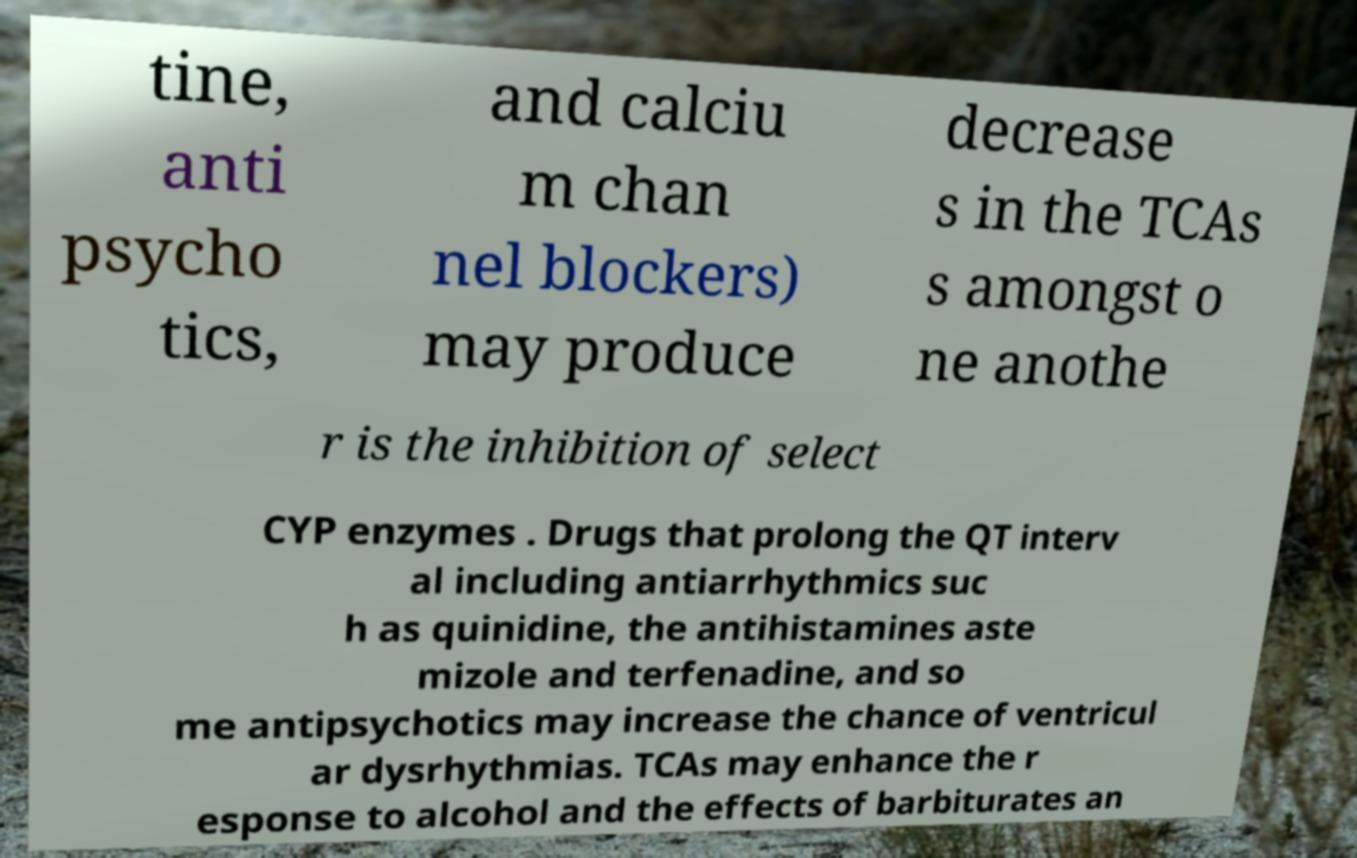There's text embedded in this image that I need extracted. Can you transcribe it verbatim? tine, anti psycho tics, and calciu m chan nel blockers) may produce decrease s in the TCAs s amongst o ne anothe r is the inhibition of select CYP enzymes . Drugs that prolong the QT interv al including antiarrhythmics suc h as quinidine, the antihistamines aste mizole and terfenadine, and so me antipsychotics may increase the chance of ventricul ar dysrhythmias. TCAs may enhance the r esponse to alcohol and the effects of barbiturates an 